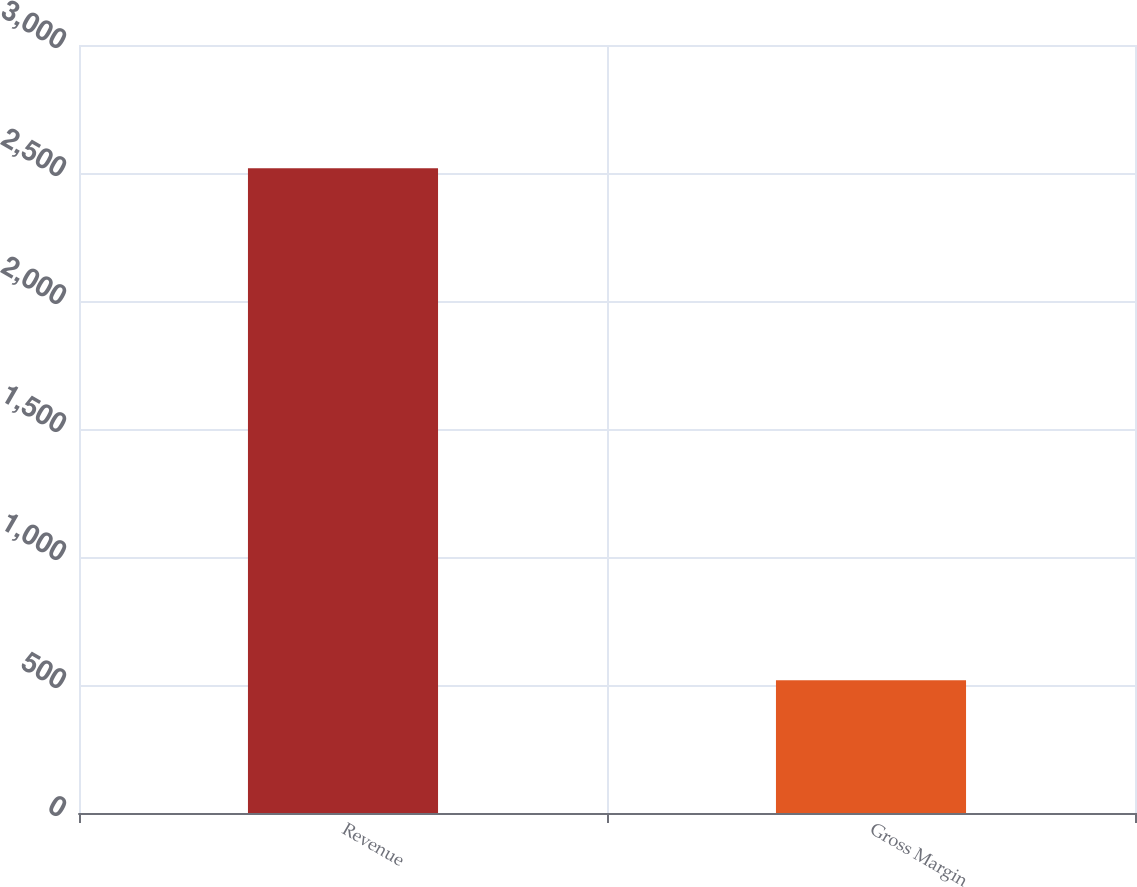<chart> <loc_0><loc_0><loc_500><loc_500><bar_chart><fcel>Revenue<fcel>Gross Margin<nl><fcel>2519<fcel>519<nl></chart> 